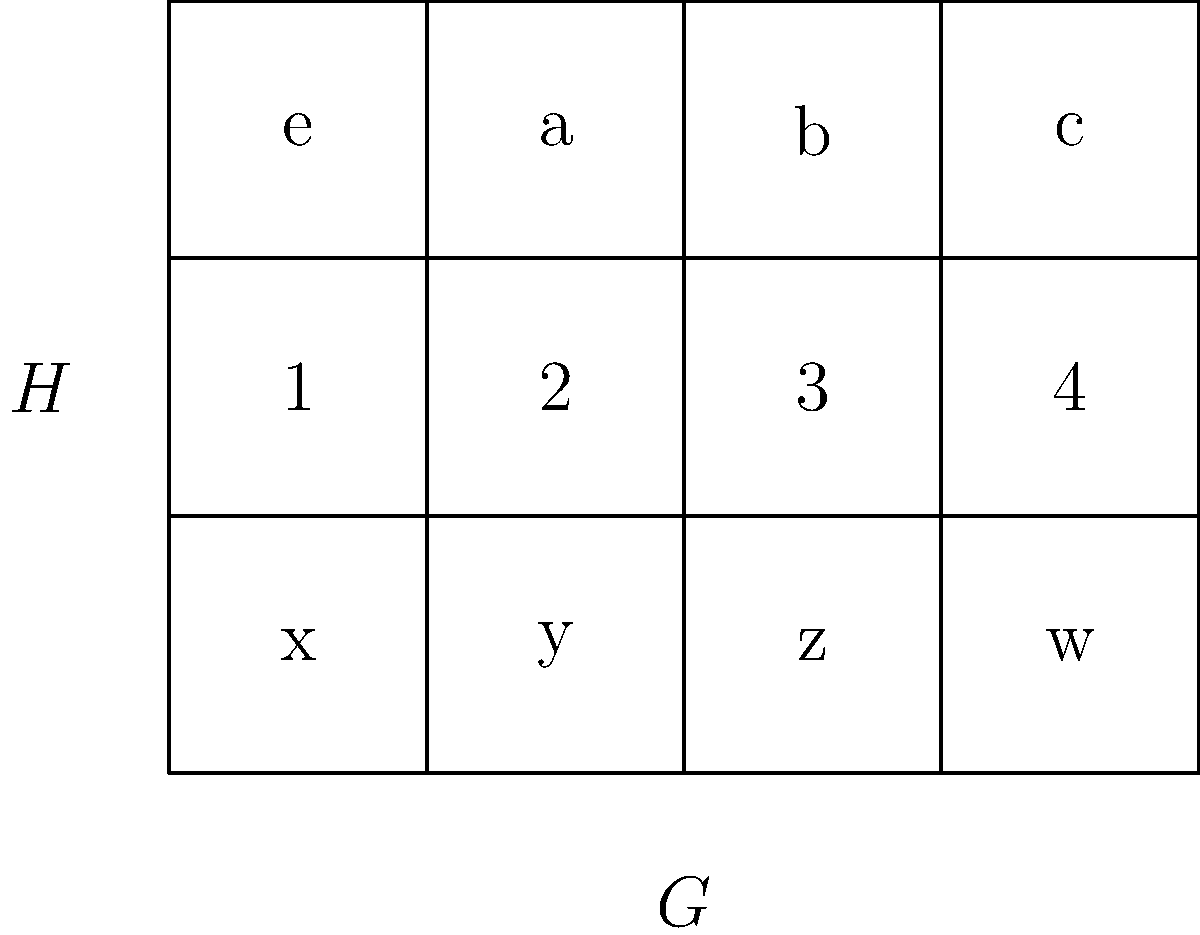As a CTO leveraging IT solutions, you're exploring group theory to optimize system architectures. Given the direct product of two groups $G \times H$ represented in the grid above, where $G = \{e, a, b, c\}$ and $H = \{1, x\}$, what is the order of the element $(b, x)$ in the product group? To find the order of the element $(b, x)$ in the direct product $G \times H$, we need to follow these steps:

1) Recall that the order of an element in a direct product is the least common multiple (LCM) of the orders of its components in their respective groups.

2) First, determine the order of $b$ in group $G$:
   - We need to find the smallest positive integer $m$ such that $b^m = e$.
   - Without more information about group $G$, we can't determine this precisely.
   - Let's denote the order of $b$ as $|b|$.

3) Next, determine the order of $x$ in group $H$:
   - We can see that $H$ has two elements, so it must be isomorphic to $\mathbb{Z}_2$.
   - In $\mathbb{Z}_2$, any non-identity element has order 2.
   - Therefore, $|x| = 2$.

4) The order of $(b, x)$ is the LCM of $|b|$ and $|x|$:
   $|(b, x)| = \text{LCM}(|b|, 2)$

5) We know that $|b|$ must divide $|G| = 4$, so $|b|$ can be either 2 or 4.

6) If $|b| = 2$, then $\text{LCM}(2, 2) = 2$
   If $|b| = 4$, then $\text{LCM}(4, 2) = 4$

Therefore, the order of $(b, x)$ is either 2 or 4, depending on the order of $b$ in $G$.
Answer: 2 or 4 